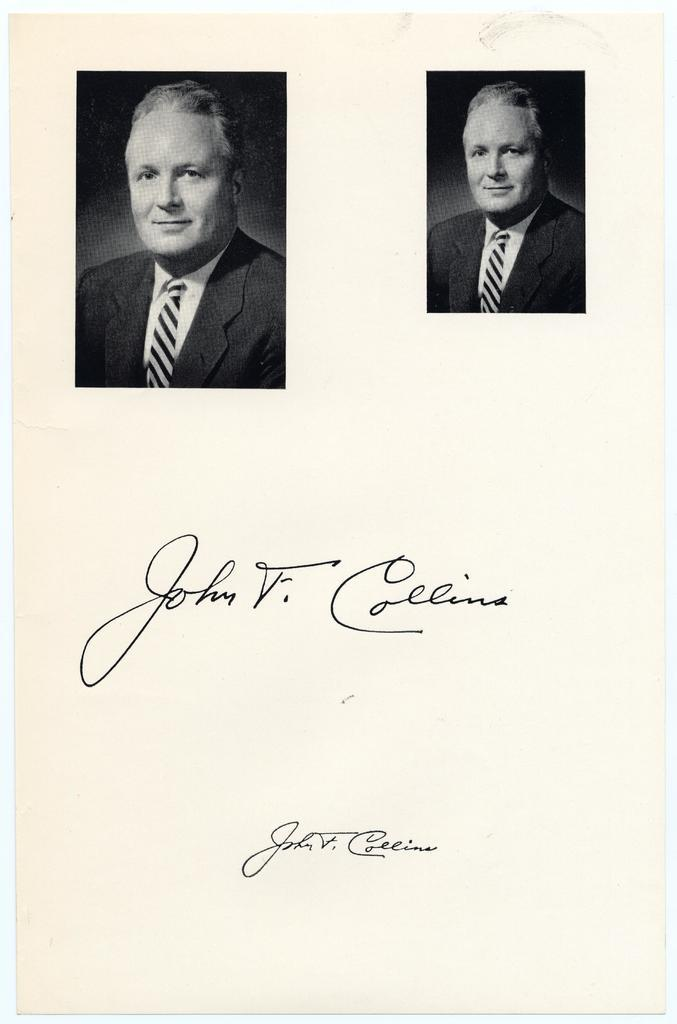What type of images are present in the image? There are two black and white pictures of a person in the image. What else can be seen in the image besides the pictures? There are two signatures on a paper in the image. What type of verse can be heard recited by the toad in the image? There is no toad or verse present in the image. 